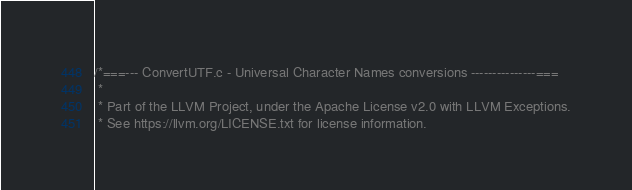Convert code to text. <code><loc_0><loc_0><loc_500><loc_500><_C++_>/*===--- ConvertUTF.c - Universal Character Names conversions ---------------===
 *
 * Part of the LLVM Project, under the Apache License v2.0 with LLVM Exceptions.
 * See https://llvm.org/LICENSE.txt for license information.</code> 